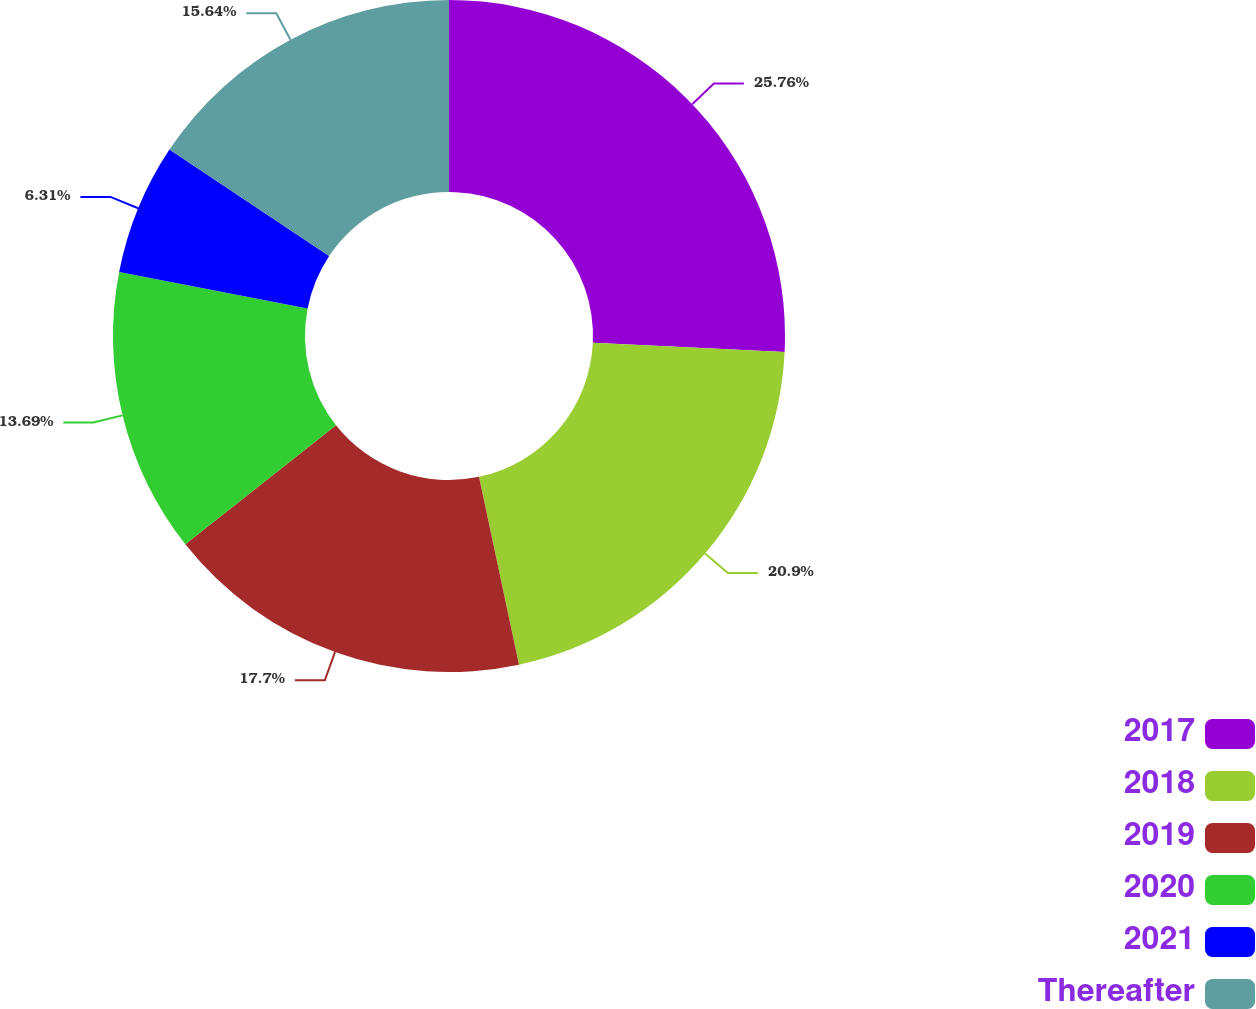<chart> <loc_0><loc_0><loc_500><loc_500><pie_chart><fcel>2017<fcel>2018<fcel>2019<fcel>2020<fcel>2021<fcel>Thereafter<nl><fcel>25.76%<fcel>20.9%<fcel>17.7%<fcel>13.69%<fcel>6.31%<fcel>15.64%<nl></chart> 